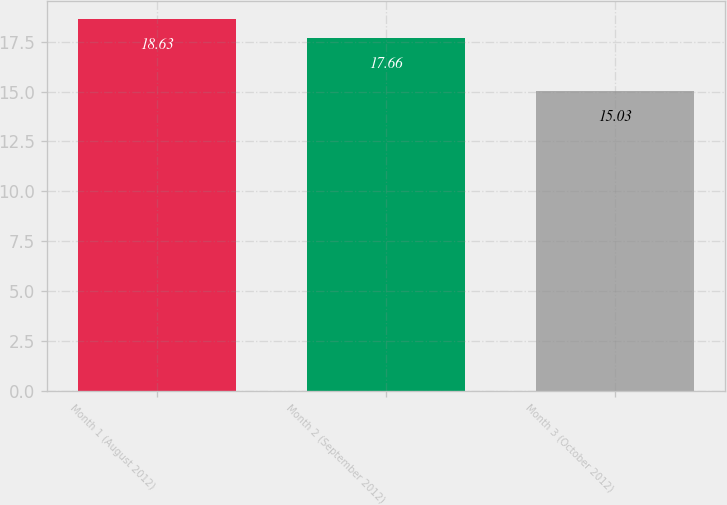Convert chart. <chart><loc_0><loc_0><loc_500><loc_500><bar_chart><fcel>Month 1 (August 2012)<fcel>Month 2 (September 2012)<fcel>Month 3 (October 2012)<nl><fcel>18.63<fcel>17.66<fcel>15.03<nl></chart> 